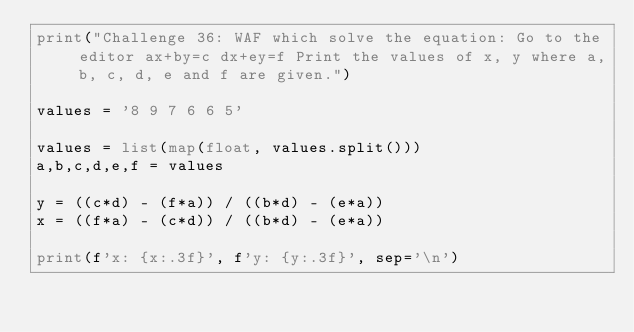<code> <loc_0><loc_0><loc_500><loc_500><_Python_>print("Challenge 36: WAF which solve the equation: Go to the editor ax+by=c dx+ey=f Print the values of x, y where a, b, c, d, e and f are given.")

values = '8 9 7 6 6 5'

values = list(map(float, values.split()))
a,b,c,d,e,f = values

y = ((c*d) - (f*a)) / ((b*d) - (e*a))
x = ((f*a) - (c*d)) / ((b*d) - (e*a))

print(f'x: {x:.3f}', f'y: {y:.3f}', sep='\n')</code> 